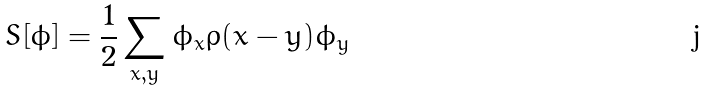<formula> <loc_0><loc_0><loc_500><loc_500>S [ \phi ] = \frac { 1 } { 2 } \sum _ { x , y } \phi _ { x } \rho ( x - y ) \phi _ { y }</formula> 